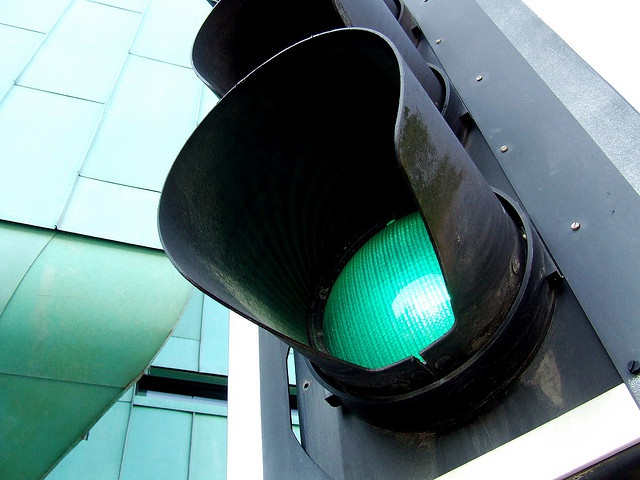Describe the objects in this image and their specific colors. I can see a traffic light in lightblue, black, white, and gray tones in this image. 